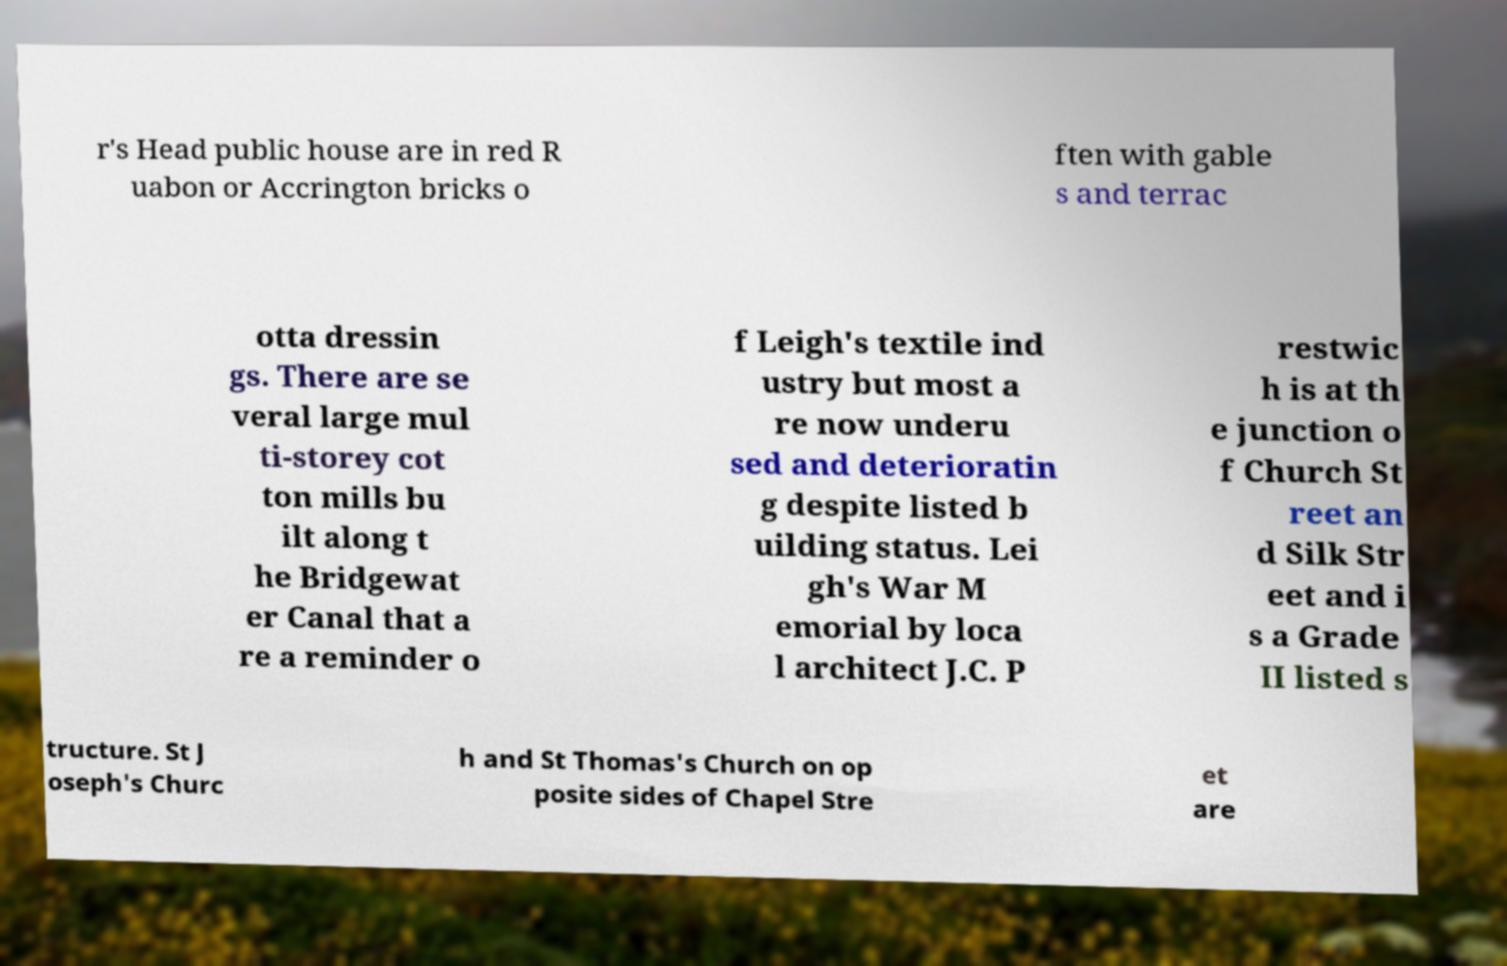What messages or text are displayed in this image? I need them in a readable, typed format. r's Head public house are in red R uabon or Accrington bricks o ften with gable s and terrac otta dressin gs. There are se veral large mul ti-storey cot ton mills bu ilt along t he Bridgewat er Canal that a re a reminder o f Leigh's textile ind ustry but most a re now underu sed and deterioratin g despite listed b uilding status. Lei gh's War M emorial by loca l architect J.C. P restwic h is at th e junction o f Church St reet an d Silk Str eet and i s a Grade II listed s tructure. St J oseph's Churc h and St Thomas's Church on op posite sides of Chapel Stre et are 